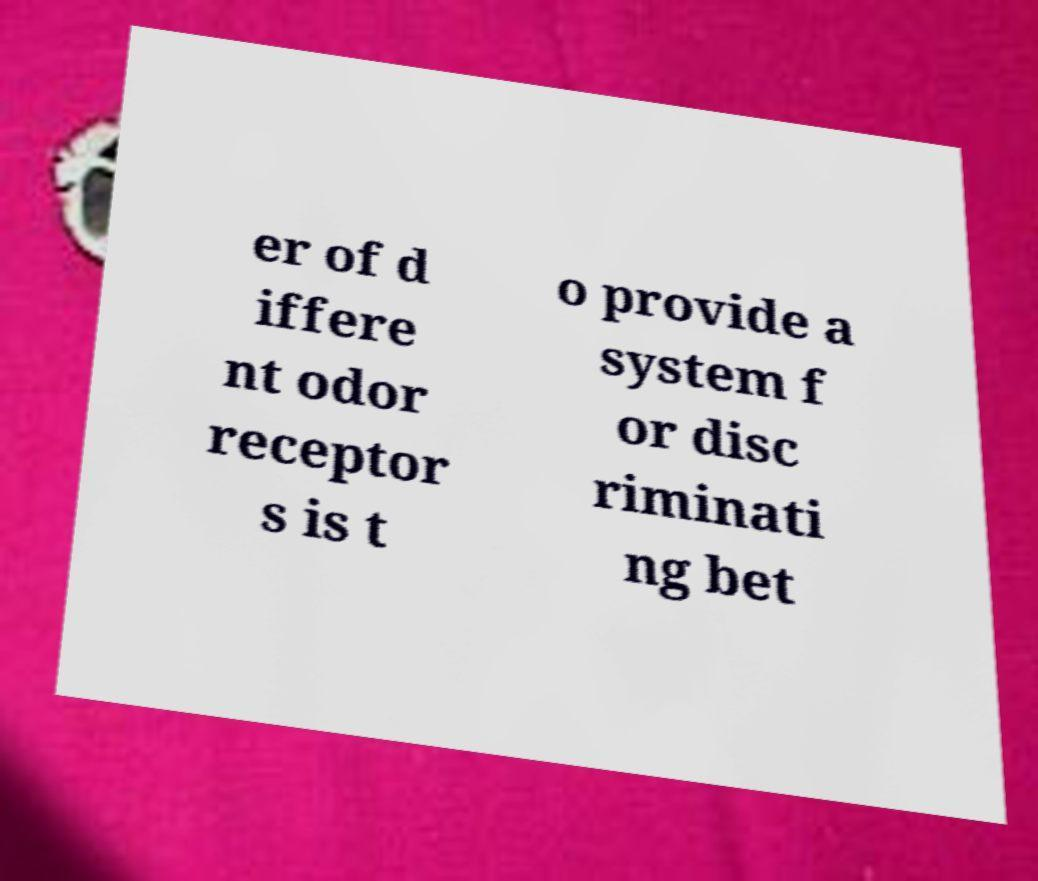Please read and relay the text visible in this image. What does it say? er of d iffere nt odor receptor s is t o provide a system f or disc riminati ng bet 